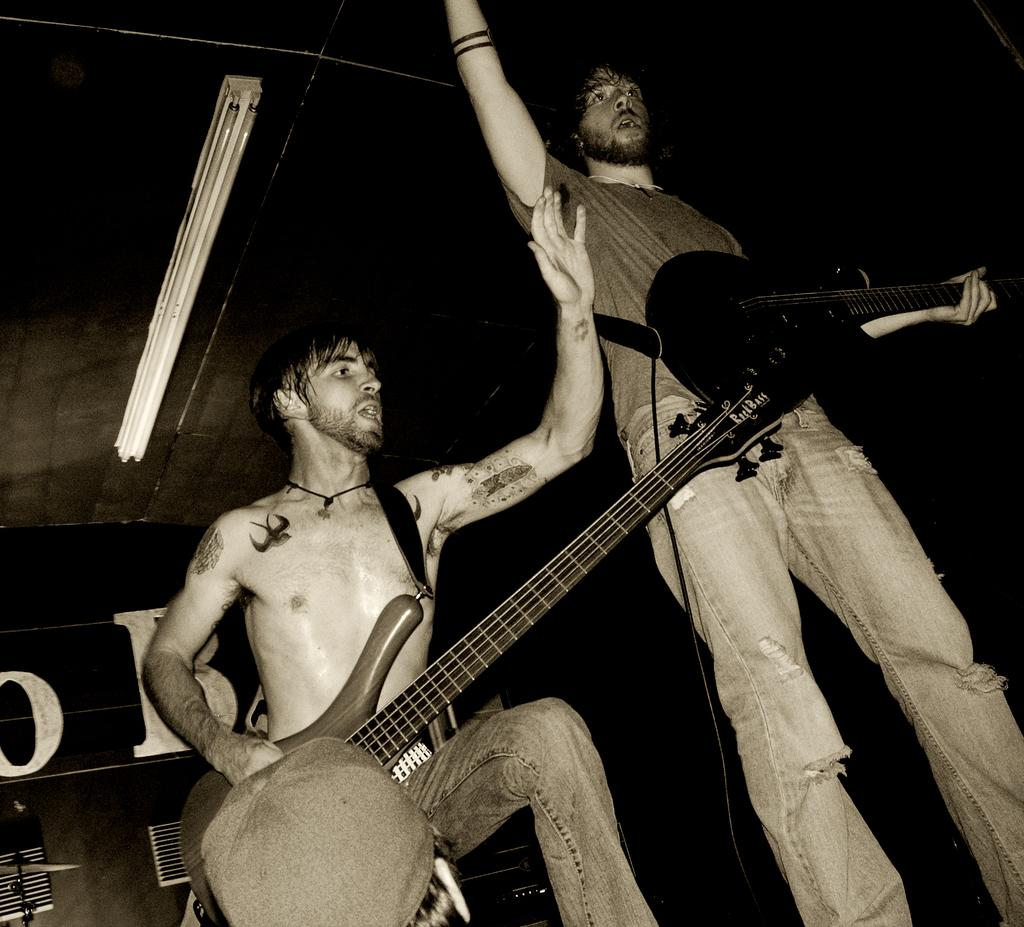How many people are in the image? There are two people in the image. What are the people doing in the image? Both people are playing guitars. What can be seen in the background of the image? There is a light and a wall in the background of the image. What type of curtain is hanging in front of the wall in the image? There is no curtain present in the image; only a wall and a light can be seen in the background. 